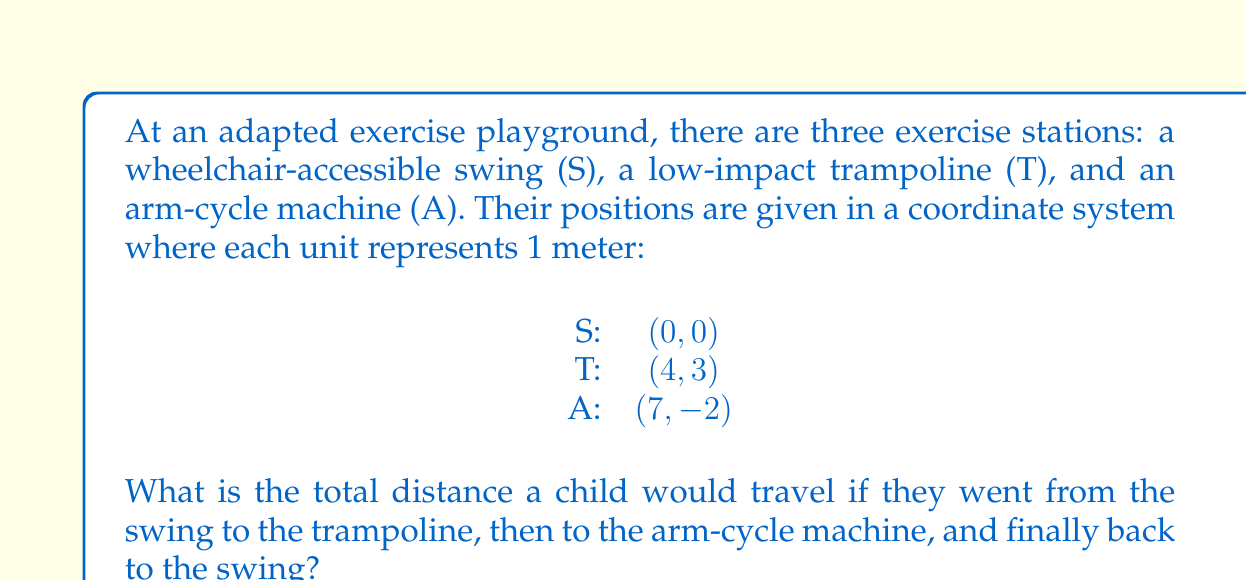Could you help me with this problem? To solve this problem, we need to calculate the distances between each pair of points and then sum them up. We can use the distance formula between two points $(x_1, y_1)$ and $(x_2, y_2)$:

$$ d = \sqrt{(x_2 - x_1)^2 + (y_2 - y_1)^2} $$

Let's calculate each distance:

1. Distance from S to T:
   $$ d_{ST} = \sqrt{(4 - 0)^2 + (3 - 0)^2} = \sqrt{16 + 9} = \sqrt{25} = 5 \text{ meters} $$

2. Distance from T to A:
   $$ d_{TA} = \sqrt{(7 - 4)^2 + (-2 - 3)^2} = \sqrt{3^2 + (-5)^2} = \sqrt{9 + 25} = \sqrt{34} \approx 5.83 \text{ meters} $$

3. Distance from A back to S:
   $$ d_{AS} = \sqrt{(0 - 7)^2 + (0 - (-2))^2} = \sqrt{(-7)^2 + 2^2} = \sqrt{49 + 4} = \sqrt{53} \approx 7.28 \text{ meters} $$

Now, we sum up all these distances:

$$ \text{Total distance} = d_{ST} + d_{TA} + d_{AS} = 5 + \sqrt{34} + \sqrt{53} \approx 5 + 5.83 + 7.28 = 18.11 \text{ meters} $$
Answer: The total distance traveled is approximately 18.11 meters. 